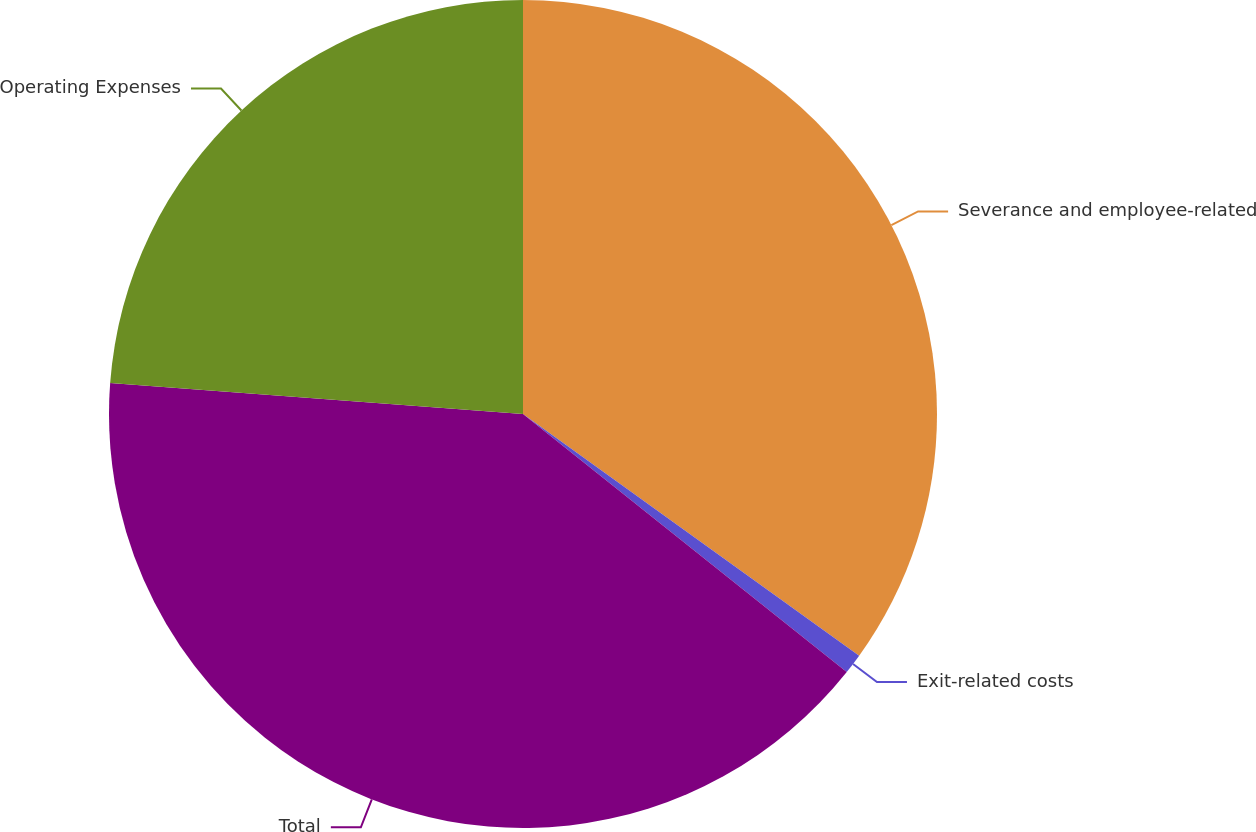<chart> <loc_0><loc_0><loc_500><loc_500><pie_chart><fcel>Severance and employee-related<fcel>Exit-related costs<fcel>Total<fcel>Operating Expenses<nl><fcel>34.92%<fcel>0.79%<fcel>40.48%<fcel>23.81%<nl></chart> 